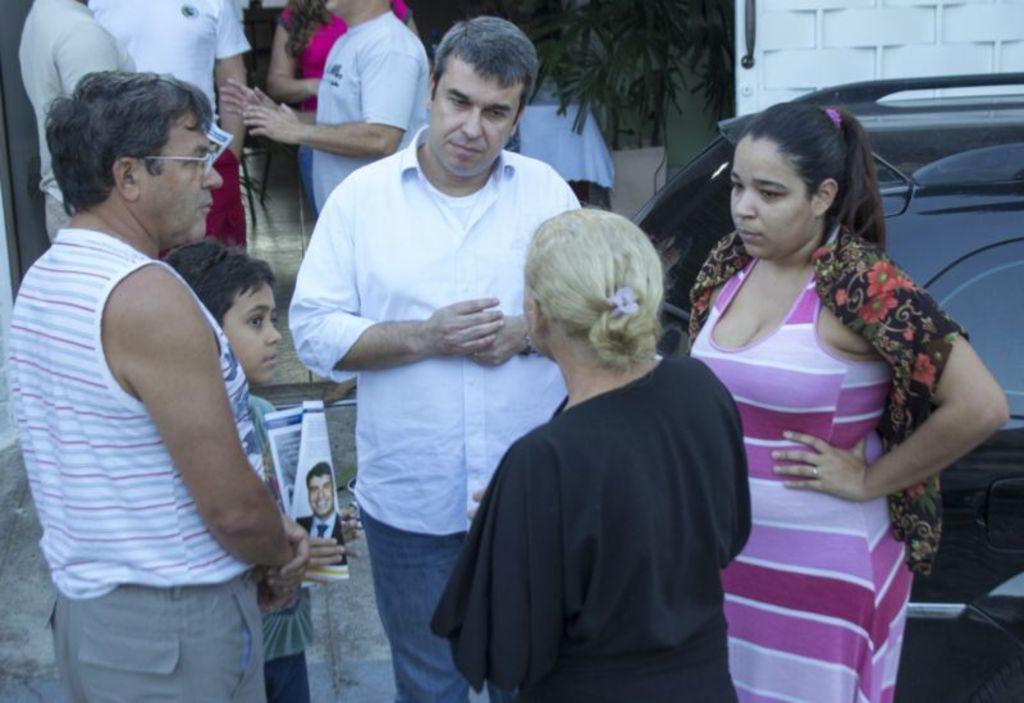How would you summarize this image in a sentence or two? In this image I can see there are few persons visible and I can see a boy ,holding a paper on his hand and I can see a vehicle visible on the right side , at the top I can see leaves of the tree 